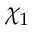Convert formula to latex. <formula><loc_0><loc_0><loc_500><loc_500>\chi _ { 1 }</formula> 